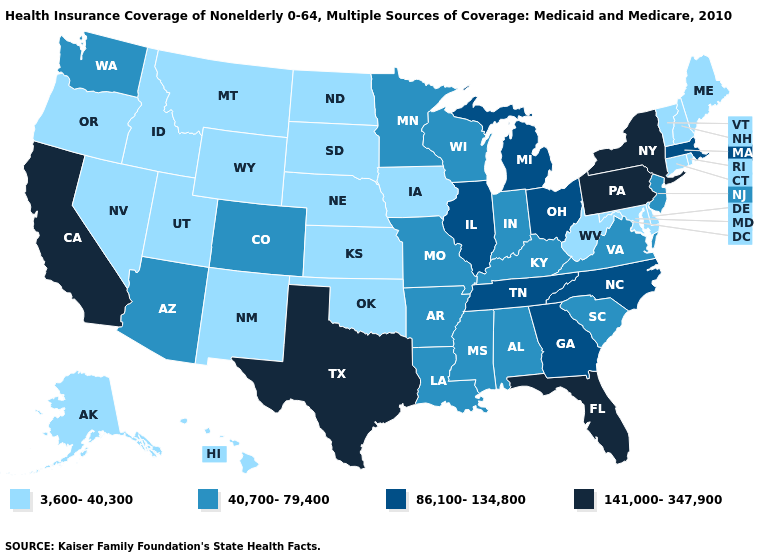Is the legend a continuous bar?
Short answer required. No. Which states have the highest value in the USA?
Be succinct. California, Florida, New York, Pennsylvania, Texas. Is the legend a continuous bar?
Be succinct. No. Does Alaska have the highest value in the USA?
Give a very brief answer. No. What is the value of Utah?
Concise answer only. 3,600-40,300. What is the value of North Carolina?
Short answer required. 86,100-134,800. Which states have the highest value in the USA?
Concise answer only. California, Florida, New York, Pennsylvania, Texas. What is the value of Washington?
Concise answer only. 40,700-79,400. What is the value of Pennsylvania?
Answer briefly. 141,000-347,900. What is the value of Indiana?
Keep it brief. 40,700-79,400. What is the value of Michigan?
Give a very brief answer. 86,100-134,800. What is the value of Colorado?
Short answer required. 40,700-79,400. How many symbols are there in the legend?
Keep it brief. 4. What is the highest value in the West ?
Concise answer only. 141,000-347,900. Does Colorado have a higher value than Michigan?
Answer briefly. No. 